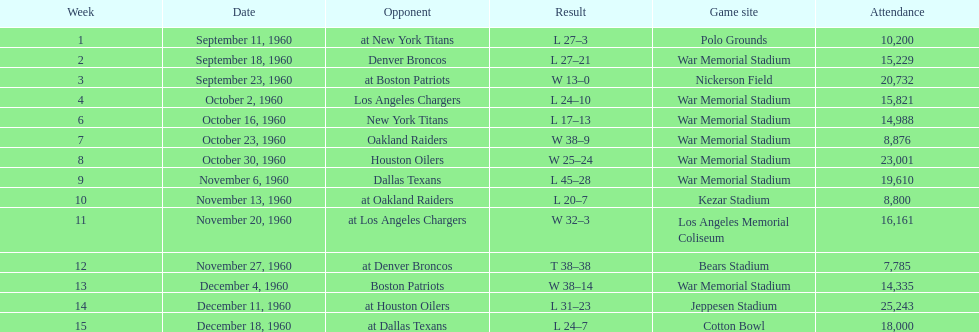How many games had an attendance of 10,000 at most? 11. Could you parse the entire table as a dict? {'header': ['Week', 'Date', 'Opponent', 'Result', 'Game site', 'Attendance'], 'rows': [['1', 'September 11, 1960', 'at New York Titans', 'L 27–3', 'Polo Grounds', '10,200'], ['2', 'September 18, 1960', 'Denver Broncos', 'L 27–21', 'War Memorial Stadium', '15,229'], ['3', 'September 23, 1960', 'at Boston Patriots', 'W 13–0', 'Nickerson Field', '20,732'], ['4', 'October 2, 1960', 'Los Angeles Chargers', 'L 24–10', 'War Memorial Stadium', '15,821'], ['6', 'October 16, 1960', 'New York Titans', 'L 17–13', 'War Memorial Stadium', '14,988'], ['7', 'October 23, 1960', 'Oakland Raiders', 'W 38–9', 'War Memorial Stadium', '8,876'], ['8', 'October 30, 1960', 'Houston Oilers', 'W 25–24', 'War Memorial Stadium', '23,001'], ['9', 'November 6, 1960', 'Dallas Texans', 'L 45–28', 'War Memorial Stadium', '19,610'], ['10', 'November 13, 1960', 'at Oakland Raiders', 'L 20–7', 'Kezar Stadium', '8,800'], ['11', 'November 20, 1960', 'at Los Angeles Chargers', 'W 32–3', 'Los Angeles Memorial Coliseum', '16,161'], ['12', 'November 27, 1960', 'at Denver Broncos', 'T 38–38', 'Bears Stadium', '7,785'], ['13', 'December 4, 1960', 'Boston Patriots', 'W 38–14', 'War Memorial Stadium', '14,335'], ['14', 'December 11, 1960', 'at Houston Oilers', 'L 31–23', 'Jeppesen Stadium', '25,243'], ['15', 'December 18, 1960', 'at Dallas Texans', 'L 24–7', 'Cotton Bowl', '18,000']]} 